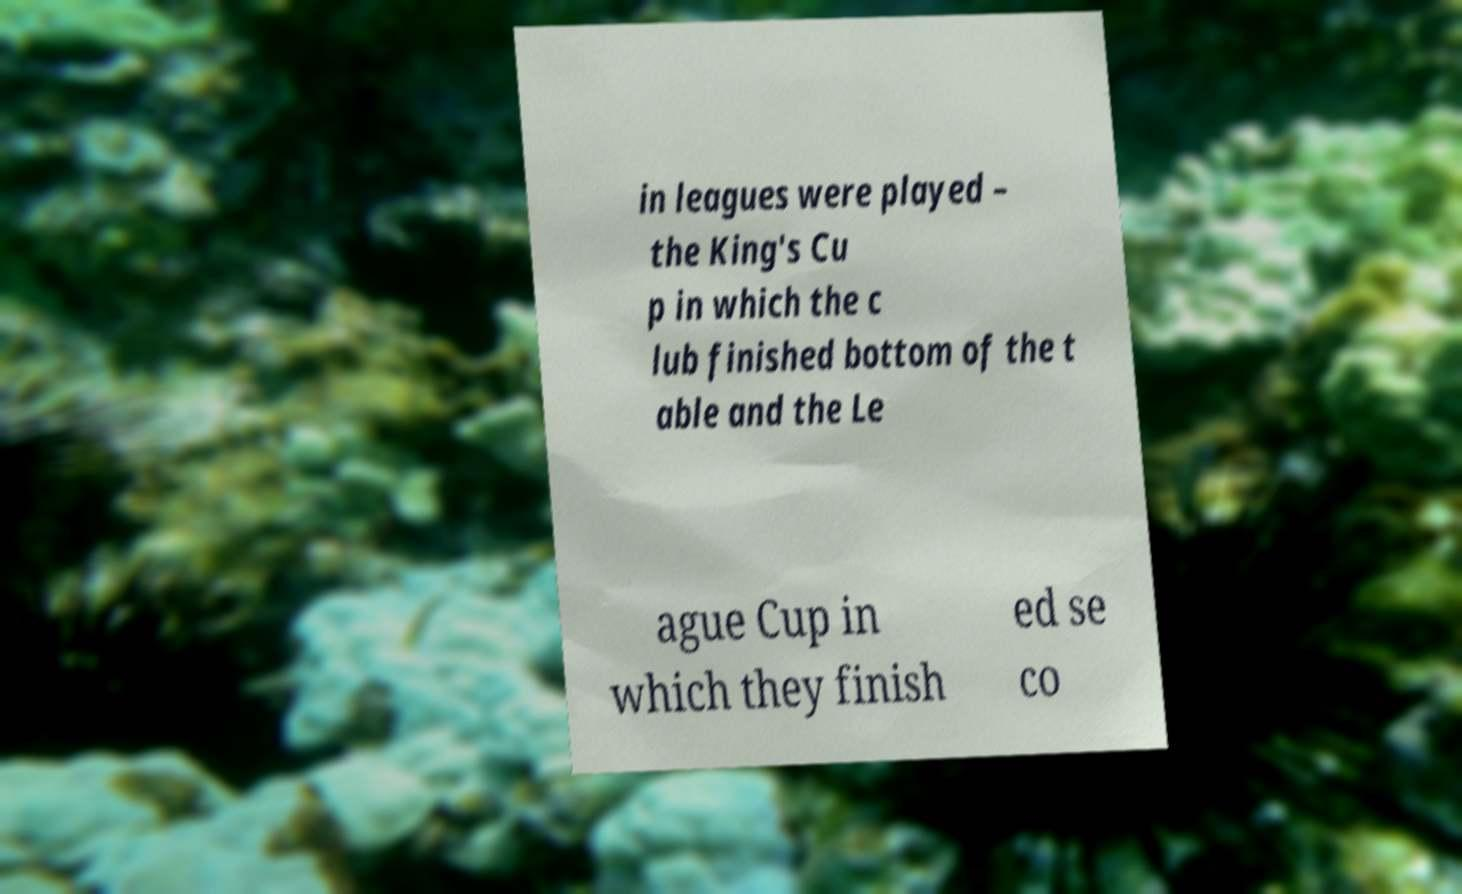Please read and relay the text visible in this image. What does it say? in leagues were played – the King's Cu p in which the c lub finished bottom of the t able and the Le ague Cup in which they finish ed se co 